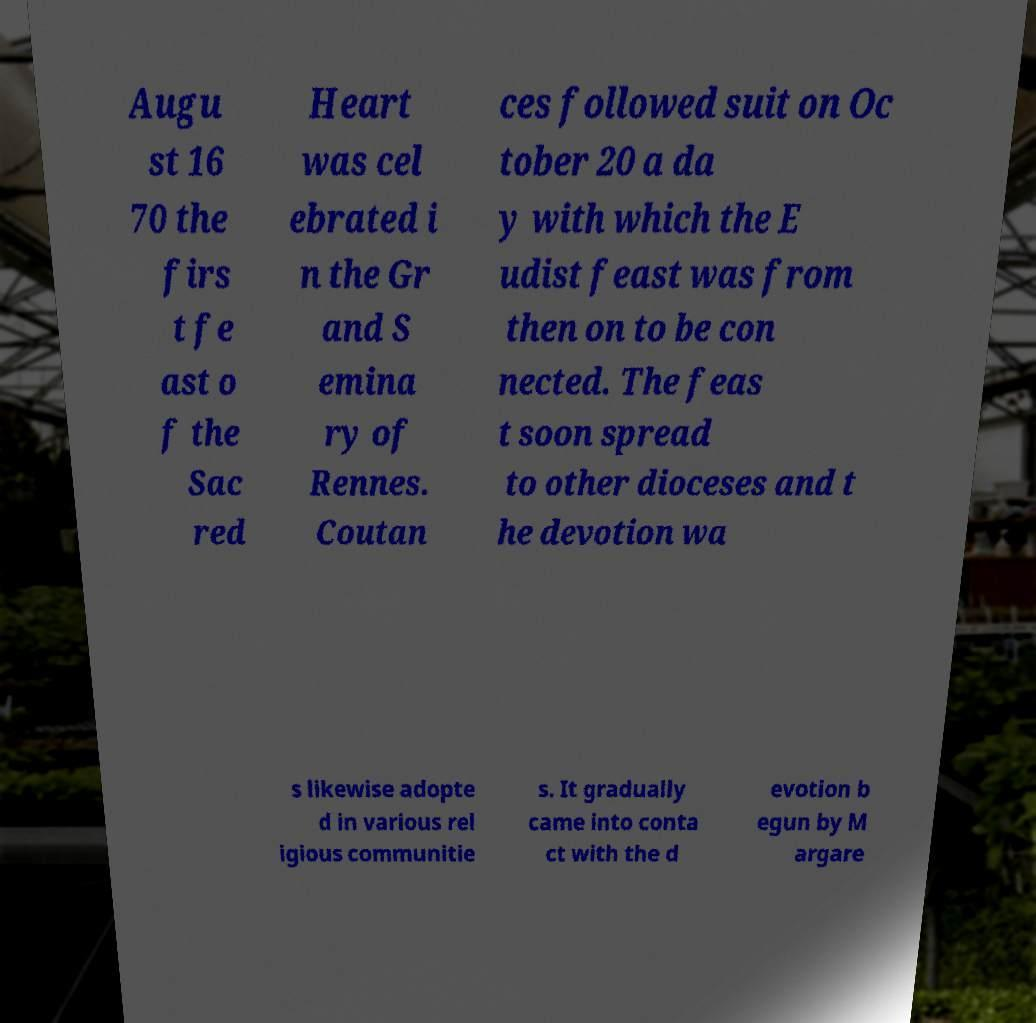Please identify and transcribe the text found in this image. Augu st 16 70 the firs t fe ast o f the Sac red Heart was cel ebrated i n the Gr and S emina ry of Rennes. Coutan ces followed suit on Oc tober 20 a da y with which the E udist feast was from then on to be con nected. The feas t soon spread to other dioceses and t he devotion wa s likewise adopte d in various rel igious communitie s. It gradually came into conta ct with the d evotion b egun by M argare 